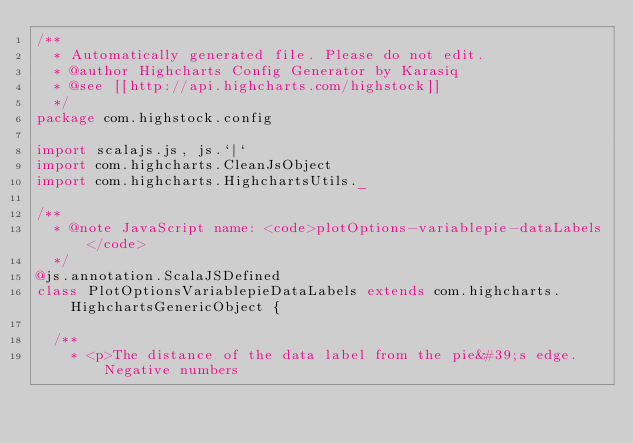<code> <loc_0><loc_0><loc_500><loc_500><_Scala_>/**
  * Automatically generated file. Please do not edit.
  * @author Highcharts Config Generator by Karasiq
  * @see [[http://api.highcharts.com/highstock]]
  */
package com.highstock.config

import scalajs.js, js.`|`
import com.highcharts.CleanJsObject
import com.highcharts.HighchartsUtils._

/**
  * @note JavaScript name: <code>plotOptions-variablepie-dataLabels</code>
  */
@js.annotation.ScalaJSDefined
class PlotOptionsVariablepieDataLabels extends com.highcharts.HighchartsGenericObject {

  /**
    * <p>The distance of the data label from the pie&#39;s edge. Negative numbers</code> 